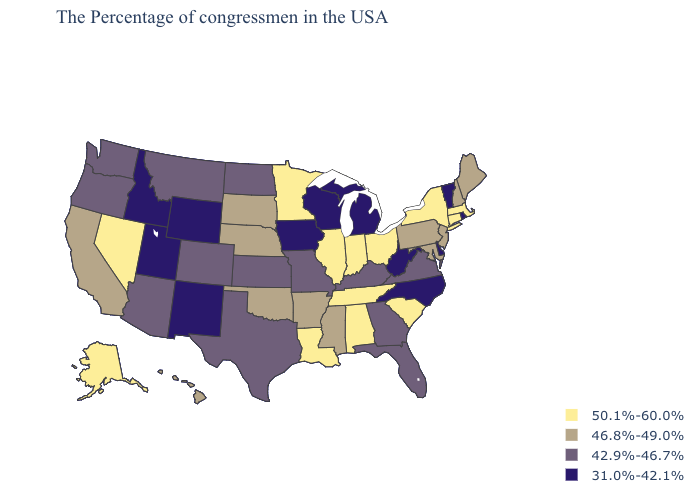What is the value of Florida?
Answer briefly. 42.9%-46.7%. Name the states that have a value in the range 31.0%-42.1%?
Short answer required. Rhode Island, Vermont, Delaware, North Carolina, West Virginia, Michigan, Wisconsin, Iowa, Wyoming, New Mexico, Utah, Idaho. Does Kentucky have a lower value than Idaho?
Quick response, please. No. What is the value of Florida?
Concise answer only. 42.9%-46.7%. What is the value of Maine?
Short answer required. 46.8%-49.0%. Name the states that have a value in the range 46.8%-49.0%?
Concise answer only. Maine, New Hampshire, New Jersey, Maryland, Pennsylvania, Mississippi, Arkansas, Nebraska, Oklahoma, South Dakota, California, Hawaii. Does North Dakota have a lower value than South Carolina?
Be succinct. Yes. Is the legend a continuous bar?
Short answer required. No. What is the value of Colorado?
Short answer required. 42.9%-46.7%. Does Massachusetts have the lowest value in the Northeast?
Keep it brief. No. What is the highest value in the South ?
Give a very brief answer. 50.1%-60.0%. Name the states that have a value in the range 46.8%-49.0%?
Quick response, please. Maine, New Hampshire, New Jersey, Maryland, Pennsylvania, Mississippi, Arkansas, Nebraska, Oklahoma, South Dakota, California, Hawaii. Which states hav the highest value in the MidWest?
Quick response, please. Ohio, Indiana, Illinois, Minnesota. What is the highest value in the West ?
Short answer required. 50.1%-60.0%. Which states hav the highest value in the MidWest?
Be succinct. Ohio, Indiana, Illinois, Minnesota. 